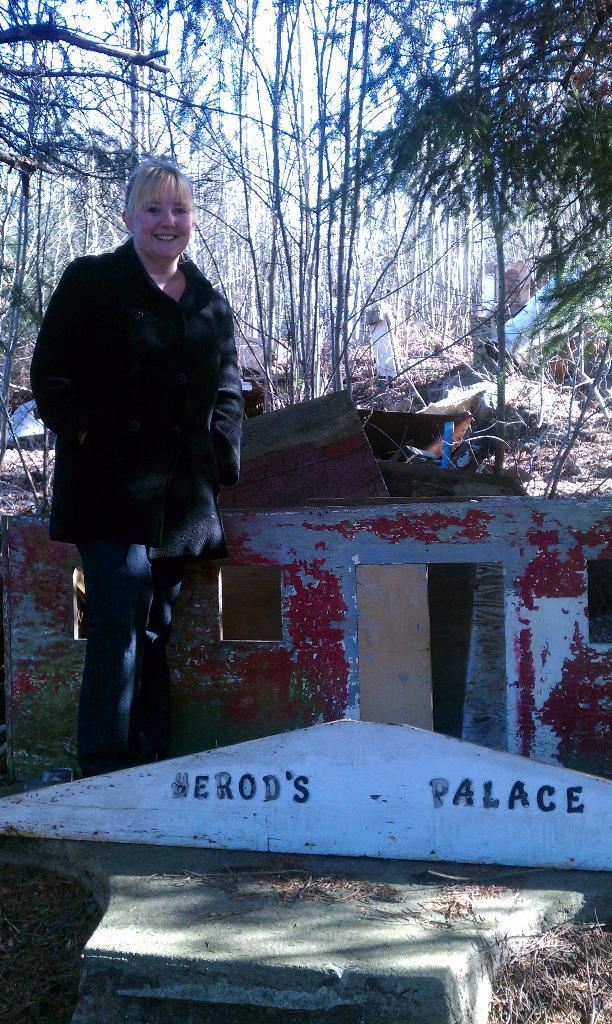Please provide a concise description of this image. In this picture we can see the text on an object. We can see a woman standing and smiling. There are trees and other objects. 